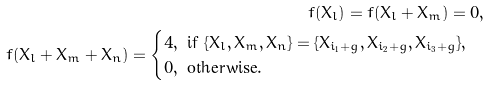Convert formula to latex. <formula><loc_0><loc_0><loc_500><loc_500>f ( X _ { l } ) = f ( X _ { l } + X _ { m } ) = 0 , \\ f ( X _ { l } + X _ { m } + X _ { n } ) = \begin{cases} 4 , \text { if } \{ X _ { l } , X _ { m } , X _ { n } \} = \{ X _ { i _ { 1 } + g } , X _ { i _ { 2 } + g } , X _ { i _ { 3 } + g } \} , \\ 0 , \text { otherwise} . \end{cases}</formula> 